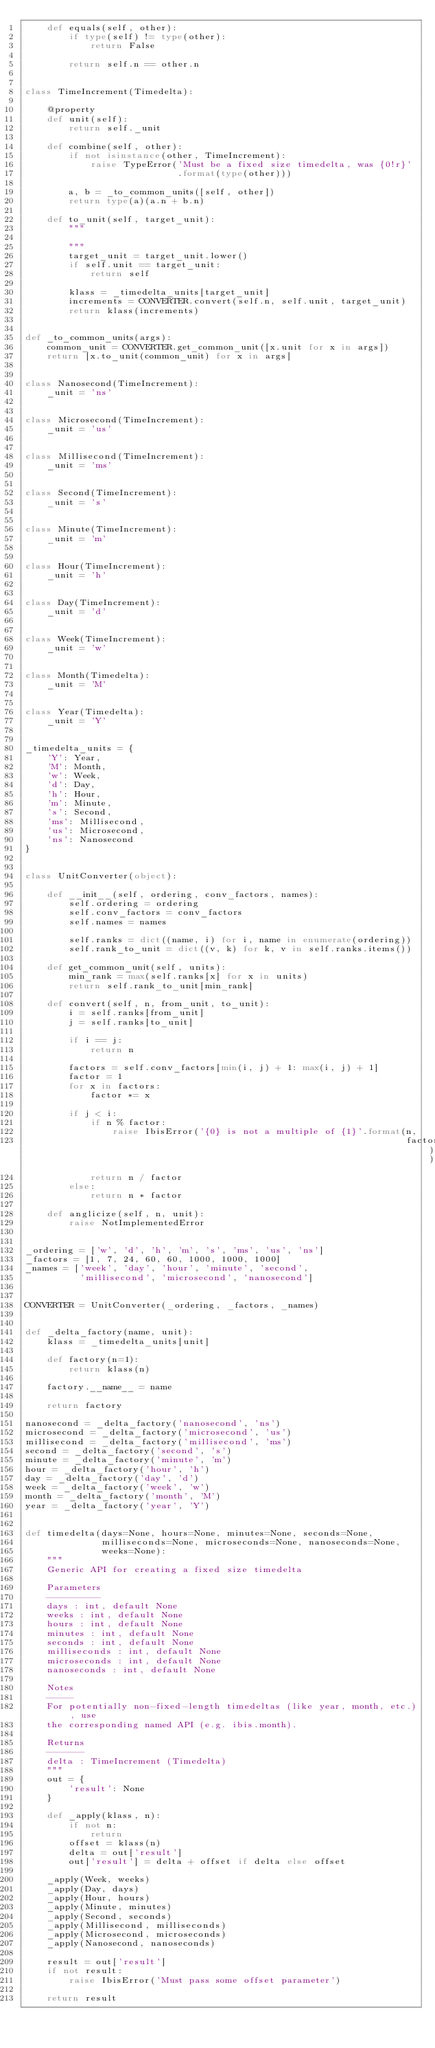<code> <loc_0><loc_0><loc_500><loc_500><_Python_>    def equals(self, other):
        if type(self) != type(other):
            return False

        return self.n == other.n


class TimeIncrement(Timedelta):

    @property
    def unit(self):
        return self._unit

    def combine(self, other):
        if not isinstance(other, TimeIncrement):
            raise TypeError('Must be a fixed size timedelta, was {0!r}'
                            .format(type(other)))

        a, b = _to_common_units([self, other])
        return type(a)(a.n + b.n)

    def to_unit(self, target_unit):
        """

        """
        target_unit = target_unit.lower()
        if self.unit == target_unit:
            return self

        klass = _timedelta_units[target_unit]
        increments = CONVERTER.convert(self.n, self.unit, target_unit)
        return klass(increments)


def _to_common_units(args):
    common_unit = CONVERTER.get_common_unit([x.unit for x in args])
    return [x.to_unit(common_unit) for x in args]


class Nanosecond(TimeIncrement):
    _unit = 'ns'


class Microsecond(TimeIncrement):
    _unit = 'us'


class Millisecond(TimeIncrement):
    _unit = 'ms'


class Second(TimeIncrement):
    _unit = 's'


class Minute(TimeIncrement):
    _unit = 'm'


class Hour(TimeIncrement):
    _unit = 'h'


class Day(TimeIncrement):
    _unit = 'd'


class Week(TimeIncrement):
    _unit = 'w'


class Month(Timedelta):
    _unit = 'M'


class Year(Timedelta):
    _unit = 'Y'


_timedelta_units = {
    'Y': Year,
    'M': Month,
    'w': Week,
    'd': Day,
    'h': Hour,
    'm': Minute,
    's': Second,
    'ms': Millisecond,
    'us': Microsecond,
    'ns': Nanosecond
}


class UnitConverter(object):

    def __init__(self, ordering, conv_factors, names):
        self.ordering = ordering
        self.conv_factors = conv_factors
        self.names = names

        self.ranks = dict((name, i) for i, name in enumerate(ordering))
        self.rank_to_unit = dict((v, k) for k, v in self.ranks.items())

    def get_common_unit(self, units):
        min_rank = max(self.ranks[x] for x in units)
        return self.rank_to_unit[min_rank]

    def convert(self, n, from_unit, to_unit):
        i = self.ranks[from_unit]
        j = self.ranks[to_unit]

        if i == j:
            return n

        factors = self.conv_factors[min(i, j) + 1: max(i, j) + 1]
        factor = 1
        for x in factors:
            factor *= x

        if j < i:
            if n % factor:
                raise IbisError('{0} is not a multiple of {1}'.format(n,
                                                                      factor))
            return n / factor
        else:
            return n * factor

    def anglicize(self, n, unit):
        raise NotImplementedError


_ordering = ['w', 'd', 'h', 'm', 's', 'ms', 'us', 'ns']
_factors = [1, 7, 24, 60, 60, 1000, 1000, 1000]
_names = ['week', 'day', 'hour', 'minute', 'second',
          'millisecond', 'microsecond', 'nanosecond']


CONVERTER = UnitConverter(_ordering, _factors, _names)


def _delta_factory(name, unit):
    klass = _timedelta_units[unit]

    def factory(n=1):
        return klass(n)

    factory.__name__ = name

    return factory

nanosecond = _delta_factory('nanosecond', 'ns')
microsecond = _delta_factory('microsecond', 'us')
millisecond = _delta_factory('millisecond', 'ms')
second = _delta_factory('second', 's')
minute = _delta_factory('minute', 'm')
hour = _delta_factory('hour', 'h')
day = _delta_factory('day', 'd')
week = _delta_factory('week', 'w')
month = _delta_factory('month', 'M')
year = _delta_factory('year', 'Y')


def timedelta(days=None, hours=None, minutes=None, seconds=None,
              milliseconds=None, microseconds=None, nanoseconds=None,
              weeks=None):
    """
    Generic API for creating a fixed size timedelta

    Parameters
    ----------
    days : int, default None
    weeks : int, default None
    hours : int, default None
    minutes : int, default None
    seconds : int, default None
    milliseconds : int, default None
    microseconds : int, default None
    nanoseconds : int, default None

    Notes
    -----
    For potentially non-fixed-length timedeltas (like year, month, etc.), use
    the corresponding named API (e.g. ibis.month).

    Returns
    -------
    delta : TimeIncrement (Timedelta)
    """
    out = {
        'result': None
    }

    def _apply(klass, n):
        if not n:
            return
        offset = klass(n)
        delta = out['result']
        out['result'] = delta + offset if delta else offset

    _apply(Week, weeks)
    _apply(Day, days)
    _apply(Hour, hours)
    _apply(Minute, minutes)
    _apply(Second, seconds)
    _apply(Millisecond, milliseconds)
    _apply(Microsecond, microseconds)
    _apply(Nanosecond, nanoseconds)

    result = out['result']
    if not result:
        raise IbisError('Must pass some offset parameter')

    return result
</code> 